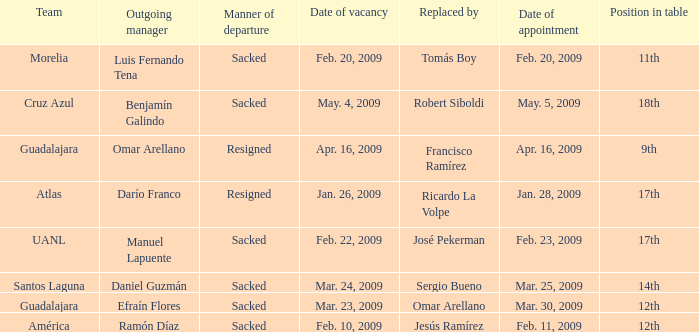What is Team, when Replaced By is "Omar Arellano"? Guadalajara. 